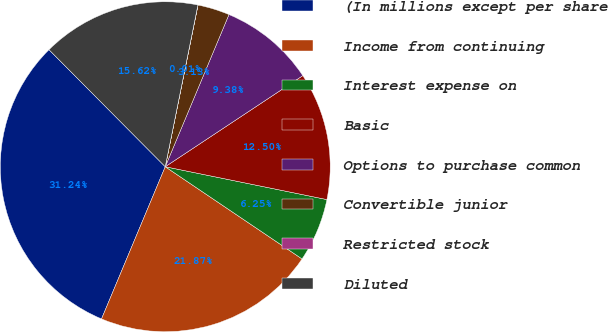Convert chart to OTSL. <chart><loc_0><loc_0><loc_500><loc_500><pie_chart><fcel>(In millions except per share<fcel>Income from continuing<fcel>Interest expense on<fcel>Basic<fcel>Options to purchase common<fcel>Convertible junior<fcel>Restricted stock<fcel>Diluted<nl><fcel>31.24%<fcel>21.87%<fcel>6.25%<fcel>12.5%<fcel>9.38%<fcel>3.13%<fcel>0.01%<fcel>15.62%<nl></chart> 